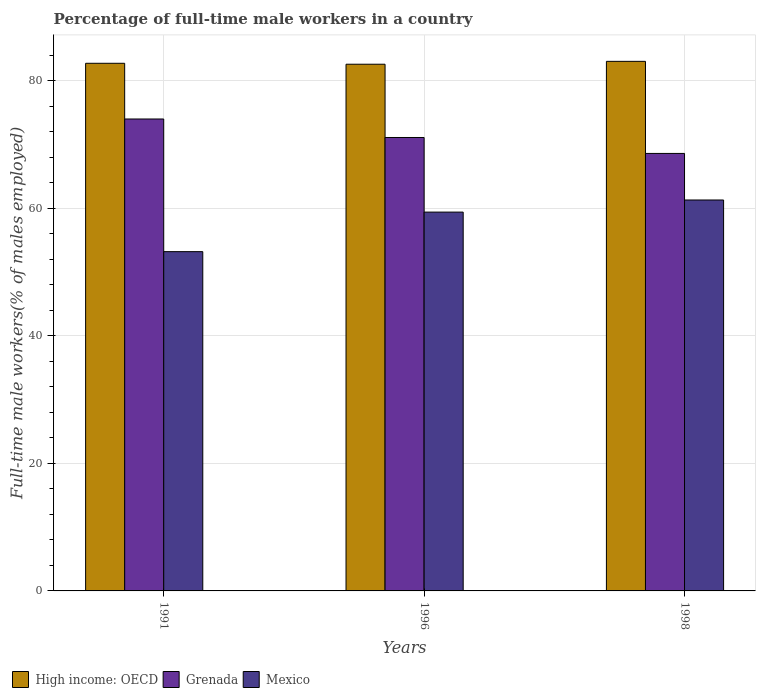How many groups of bars are there?
Ensure brevity in your answer.  3. Are the number of bars per tick equal to the number of legend labels?
Make the answer very short. Yes. Are the number of bars on each tick of the X-axis equal?
Offer a very short reply. Yes. How many bars are there on the 2nd tick from the right?
Your answer should be very brief. 3. What is the label of the 2nd group of bars from the left?
Your response must be concise. 1996. In how many cases, is the number of bars for a given year not equal to the number of legend labels?
Your answer should be compact. 0. What is the percentage of full-time male workers in High income: OECD in 1996?
Ensure brevity in your answer.  82.59. Across all years, what is the minimum percentage of full-time male workers in Mexico?
Your answer should be compact. 53.2. What is the total percentage of full-time male workers in Mexico in the graph?
Give a very brief answer. 173.9. What is the difference between the percentage of full-time male workers in High income: OECD in 1996 and that in 1998?
Keep it short and to the point. -0.45. What is the difference between the percentage of full-time male workers in High income: OECD in 1998 and the percentage of full-time male workers in Grenada in 1991?
Give a very brief answer. 9.04. What is the average percentage of full-time male workers in Grenada per year?
Your answer should be very brief. 71.23. In the year 1991, what is the difference between the percentage of full-time male workers in High income: OECD and percentage of full-time male workers in Grenada?
Make the answer very short. 8.73. What is the ratio of the percentage of full-time male workers in Grenada in 1996 to that in 1998?
Your answer should be very brief. 1.04. What is the difference between the highest and the second highest percentage of full-time male workers in Mexico?
Offer a terse response. 1.9. What is the difference between the highest and the lowest percentage of full-time male workers in High income: OECD?
Ensure brevity in your answer.  0.45. Is the sum of the percentage of full-time male workers in Grenada in 1991 and 1998 greater than the maximum percentage of full-time male workers in High income: OECD across all years?
Give a very brief answer. Yes. What does the 1st bar from the left in 1996 represents?
Your response must be concise. High income: OECD. What does the 2nd bar from the right in 1991 represents?
Ensure brevity in your answer.  Grenada. Is it the case that in every year, the sum of the percentage of full-time male workers in High income: OECD and percentage of full-time male workers in Mexico is greater than the percentage of full-time male workers in Grenada?
Ensure brevity in your answer.  Yes. How many bars are there?
Make the answer very short. 9. How many years are there in the graph?
Offer a terse response. 3. Where does the legend appear in the graph?
Provide a succinct answer. Bottom left. What is the title of the graph?
Ensure brevity in your answer.  Percentage of full-time male workers in a country. What is the label or title of the X-axis?
Provide a succinct answer. Years. What is the label or title of the Y-axis?
Provide a succinct answer. Full-time male workers(% of males employed). What is the Full-time male workers(% of males employed) of High income: OECD in 1991?
Your answer should be very brief. 82.73. What is the Full-time male workers(% of males employed) in Mexico in 1991?
Keep it short and to the point. 53.2. What is the Full-time male workers(% of males employed) in High income: OECD in 1996?
Make the answer very short. 82.59. What is the Full-time male workers(% of males employed) in Grenada in 1996?
Offer a terse response. 71.1. What is the Full-time male workers(% of males employed) of Mexico in 1996?
Keep it short and to the point. 59.4. What is the Full-time male workers(% of males employed) of High income: OECD in 1998?
Offer a terse response. 83.04. What is the Full-time male workers(% of males employed) of Grenada in 1998?
Keep it short and to the point. 68.6. What is the Full-time male workers(% of males employed) of Mexico in 1998?
Ensure brevity in your answer.  61.3. Across all years, what is the maximum Full-time male workers(% of males employed) in High income: OECD?
Your response must be concise. 83.04. Across all years, what is the maximum Full-time male workers(% of males employed) of Grenada?
Your answer should be compact. 74. Across all years, what is the maximum Full-time male workers(% of males employed) in Mexico?
Give a very brief answer. 61.3. Across all years, what is the minimum Full-time male workers(% of males employed) of High income: OECD?
Your response must be concise. 82.59. Across all years, what is the minimum Full-time male workers(% of males employed) in Grenada?
Provide a succinct answer. 68.6. Across all years, what is the minimum Full-time male workers(% of males employed) in Mexico?
Your answer should be compact. 53.2. What is the total Full-time male workers(% of males employed) of High income: OECD in the graph?
Your response must be concise. 248.36. What is the total Full-time male workers(% of males employed) in Grenada in the graph?
Offer a terse response. 213.7. What is the total Full-time male workers(% of males employed) in Mexico in the graph?
Provide a succinct answer. 173.9. What is the difference between the Full-time male workers(% of males employed) of High income: OECD in 1991 and that in 1996?
Ensure brevity in your answer.  0.15. What is the difference between the Full-time male workers(% of males employed) of Mexico in 1991 and that in 1996?
Ensure brevity in your answer.  -6.2. What is the difference between the Full-time male workers(% of males employed) in High income: OECD in 1991 and that in 1998?
Ensure brevity in your answer.  -0.3. What is the difference between the Full-time male workers(% of males employed) in Mexico in 1991 and that in 1998?
Keep it short and to the point. -8.1. What is the difference between the Full-time male workers(% of males employed) of High income: OECD in 1996 and that in 1998?
Provide a succinct answer. -0.45. What is the difference between the Full-time male workers(% of males employed) of Grenada in 1996 and that in 1998?
Provide a short and direct response. 2.5. What is the difference between the Full-time male workers(% of males employed) of High income: OECD in 1991 and the Full-time male workers(% of males employed) of Grenada in 1996?
Offer a terse response. 11.63. What is the difference between the Full-time male workers(% of males employed) of High income: OECD in 1991 and the Full-time male workers(% of males employed) of Mexico in 1996?
Offer a very short reply. 23.33. What is the difference between the Full-time male workers(% of males employed) of High income: OECD in 1991 and the Full-time male workers(% of males employed) of Grenada in 1998?
Your answer should be very brief. 14.13. What is the difference between the Full-time male workers(% of males employed) in High income: OECD in 1991 and the Full-time male workers(% of males employed) in Mexico in 1998?
Give a very brief answer. 21.43. What is the difference between the Full-time male workers(% of males employed) of High income: OECD in 1996 and the Full-time male workers(% of males employed) of Grenada in 1998?
Your answer should be compact. 13.99. What is the difference between the Full-time male workers(% of males employed) of High income: OECD in 1996 and the Full-time male workers(% of males employed) of Mexico in 1998?
Provide a short and direct response. 21.29. What is the average Full-time male workers(% of males employed) in High income: OECD per year?
Offer a terse response. 82.79. What is the average Full-time male workers(% of males employed) in Grenada per year?
Make the answer very short. 71.23. What is the average Full-time male workers(% of males employed) in Mexico per year?
Provide a short and direct response. 57.97. In the year 1991, what is the difference between the Full-time male workers(% of males employed) in High income: OECD and Full-time male workers(% of males employed) in Grenada?
Offer a terse response. 8.73. In the year 1991, what is the difference between the Full-time male workers(% of males employed) of High income: OECD and Full-time male workers(% of males employed) of Mexico?
Your response must be concise. 29.53. In the year 1991, what is the difference between the Full-time male workers(% of males employed) of Grenada and Full-time male workers(% of males employed) of Mexico?
Keep it short and to the point. 20.8. In the year 1996, what is the difference between the Full-time male workers(% of males employed) in High income: OECD and Full-time male workers(% of males employed) in Grenada?
Give a very brief answer. 11.49. In the year 1996, what is the difference between the Full-time male workers(% of males employed) in High income: OECD and Full-time male workers(% of males employed) in Mexico?
Your answer should be very brief. 23.19. In the year 1996, what is the difference between the Full-time male workers(% of males employed) of Grenada and Full-time male workers(% of males employed) of Mexico?
Provide a short and direct response. 11.7. In the year 1998, what is the difference between the Full-time male workers(% of males employed) of High income: OECD and Full-time male workers(% of males employed) of Grenada?
Offer a very short reply. 14.44. In the year 1998, what is the difference between the Full-time male workers(% of males employed) in High income: OECD and Full-time male workers(% of males employed) in Mexico?
Make the answer very short. 21.74. In the year 1998, what is the difference between the Full-time male workers(% of males employed) of Grenada and Full-time male workers(% of males employed) of Mexico?
Keep it short and to the point. 7.3. What is the ratio of the Full-time male workers(% of males employed) of High income: OECD in 1991 to that in 1996?
Make the answer very short. 1. What is the ratio of the Full-time male workers(% of males employed) of Grenada in 1991 to that in 1996?
Your answer should be very brief. 1.04. What is the ratio of the Full-time male workers(% of males employed) in Mexico in 1991 to that in 1996?
Offer a very short reply. 0.9. What is the ratio of the Full-time male workers(% of males employed) in High income: OECD in 1991 to that in 1998?
Provide a short and direct response. 1. What is the ratio of the Full-time male workers(% of males employed) in Grenada in 1991 to that in 1998?
Ensure brevity in your answer.  1.08. What is the ratio of the Full-time male workers(% of males employed) of Mexico in 1991 to that in 1998?
Make the answer very short. 0.87. What is the ratio of the Full-time male workers(% of males employed) of Grenada in 1996 to that in 1998?
Provide a short and direct response. 1.04. What is the ratio of the Full-time male workers(% of males employed) of Mexico in 1996 to that in 1998?
Your answer should be compact. 0.97. What is the difference between the highest and the second highest Full-time male workers(% of males employed) in High income: OECD?
Keep it short and to the point. 0.3. What is the difference between the highest and the second highest Full-time male workers(% of males employed) in Grenada?
Give a very brief answer. 2.9. What is the difference between the highest and the lowest Full-time male workers(% of males employed) of High income: OECD?
Ensure brevity in your answer.  0.45. 